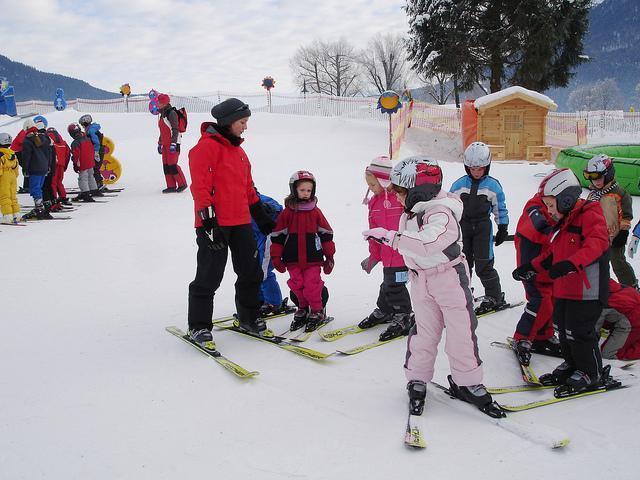Different parabolic shapes are found in?
Select the accurate answer and provide explanation: 'Answer: answer
Rationale: rationale.'
Options: Poles, surfs, snowblades, kites. Answer: snowblades.
Rationale: The skiis are different shapes. 